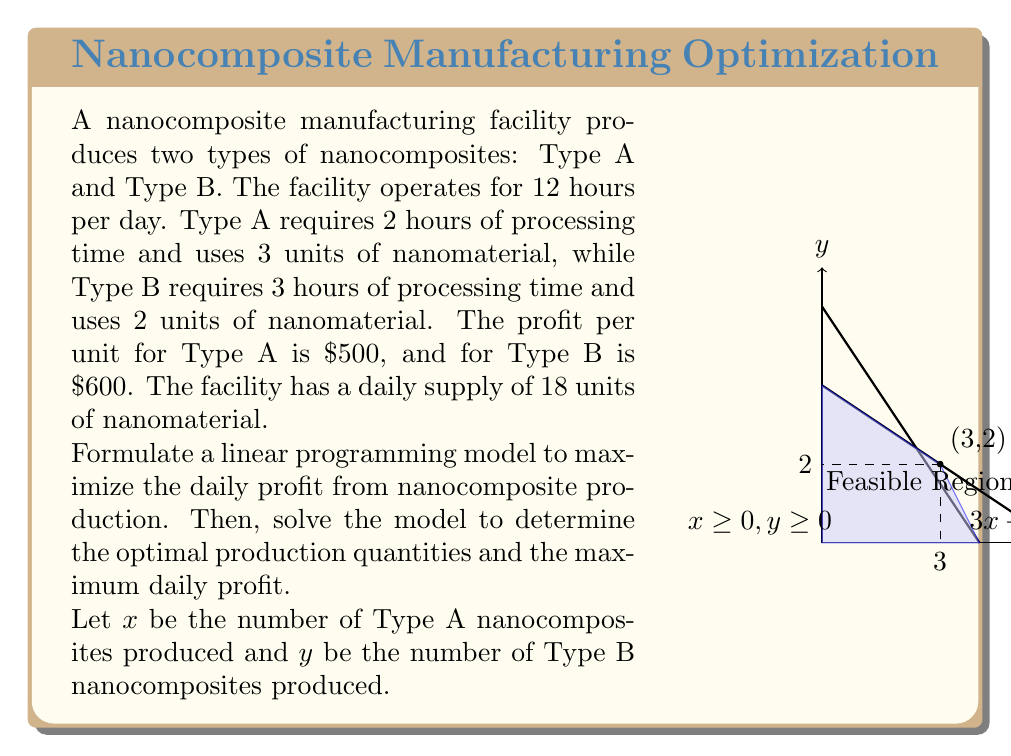Could you help me with this problem? Step 1: Formulate the linear programming model

Objective function (maximize profit):
$$Z = 500x + 600y$$

Constraints:
1. Processing time: $2x + 3y \leq 12$ (hours)
2. Nanomaterial usage: $3x + 2y \leq 18$ (units)
3. Non-negativity: $x \geq 0, y \geq 0$

Step 2: Identify the feasible region
The feasible region is bounded by the constraints, as shown in the graph in the question.

Step 3: Find the corner points of the feasible region
The corner points are (0,0), (6,0), (0,4), and the intersection of the two constraint lines.

To find the intersection point, solve the system of equations:
$$2x + 3y = 12$$
$$3x + 2y = 18$$

Solving this system yields $x = 3$ and $y = 2$.

Step 4: Evaluate the objective function at each corner point
(0,0): $Z = 500(0) + 600(0) = 0$
(6,0): $Z = 500(6) + 600(0) = 3000$
(0,4): $Z = 500(0) + 600(4) = 2400$
(3,2): $Z = 500(3) + 600(2) = 2700$

Step 5: Identify the optimal solution
The maximum value of Z occurs at the point (3,2), which represents producing 3 units of Type A and 2 units of Type B nanocomposites.

The maximum daily profit is $2700.
Answer: Optimal production: 3 Type A, 2 Type B; Maximum profit: $2700 